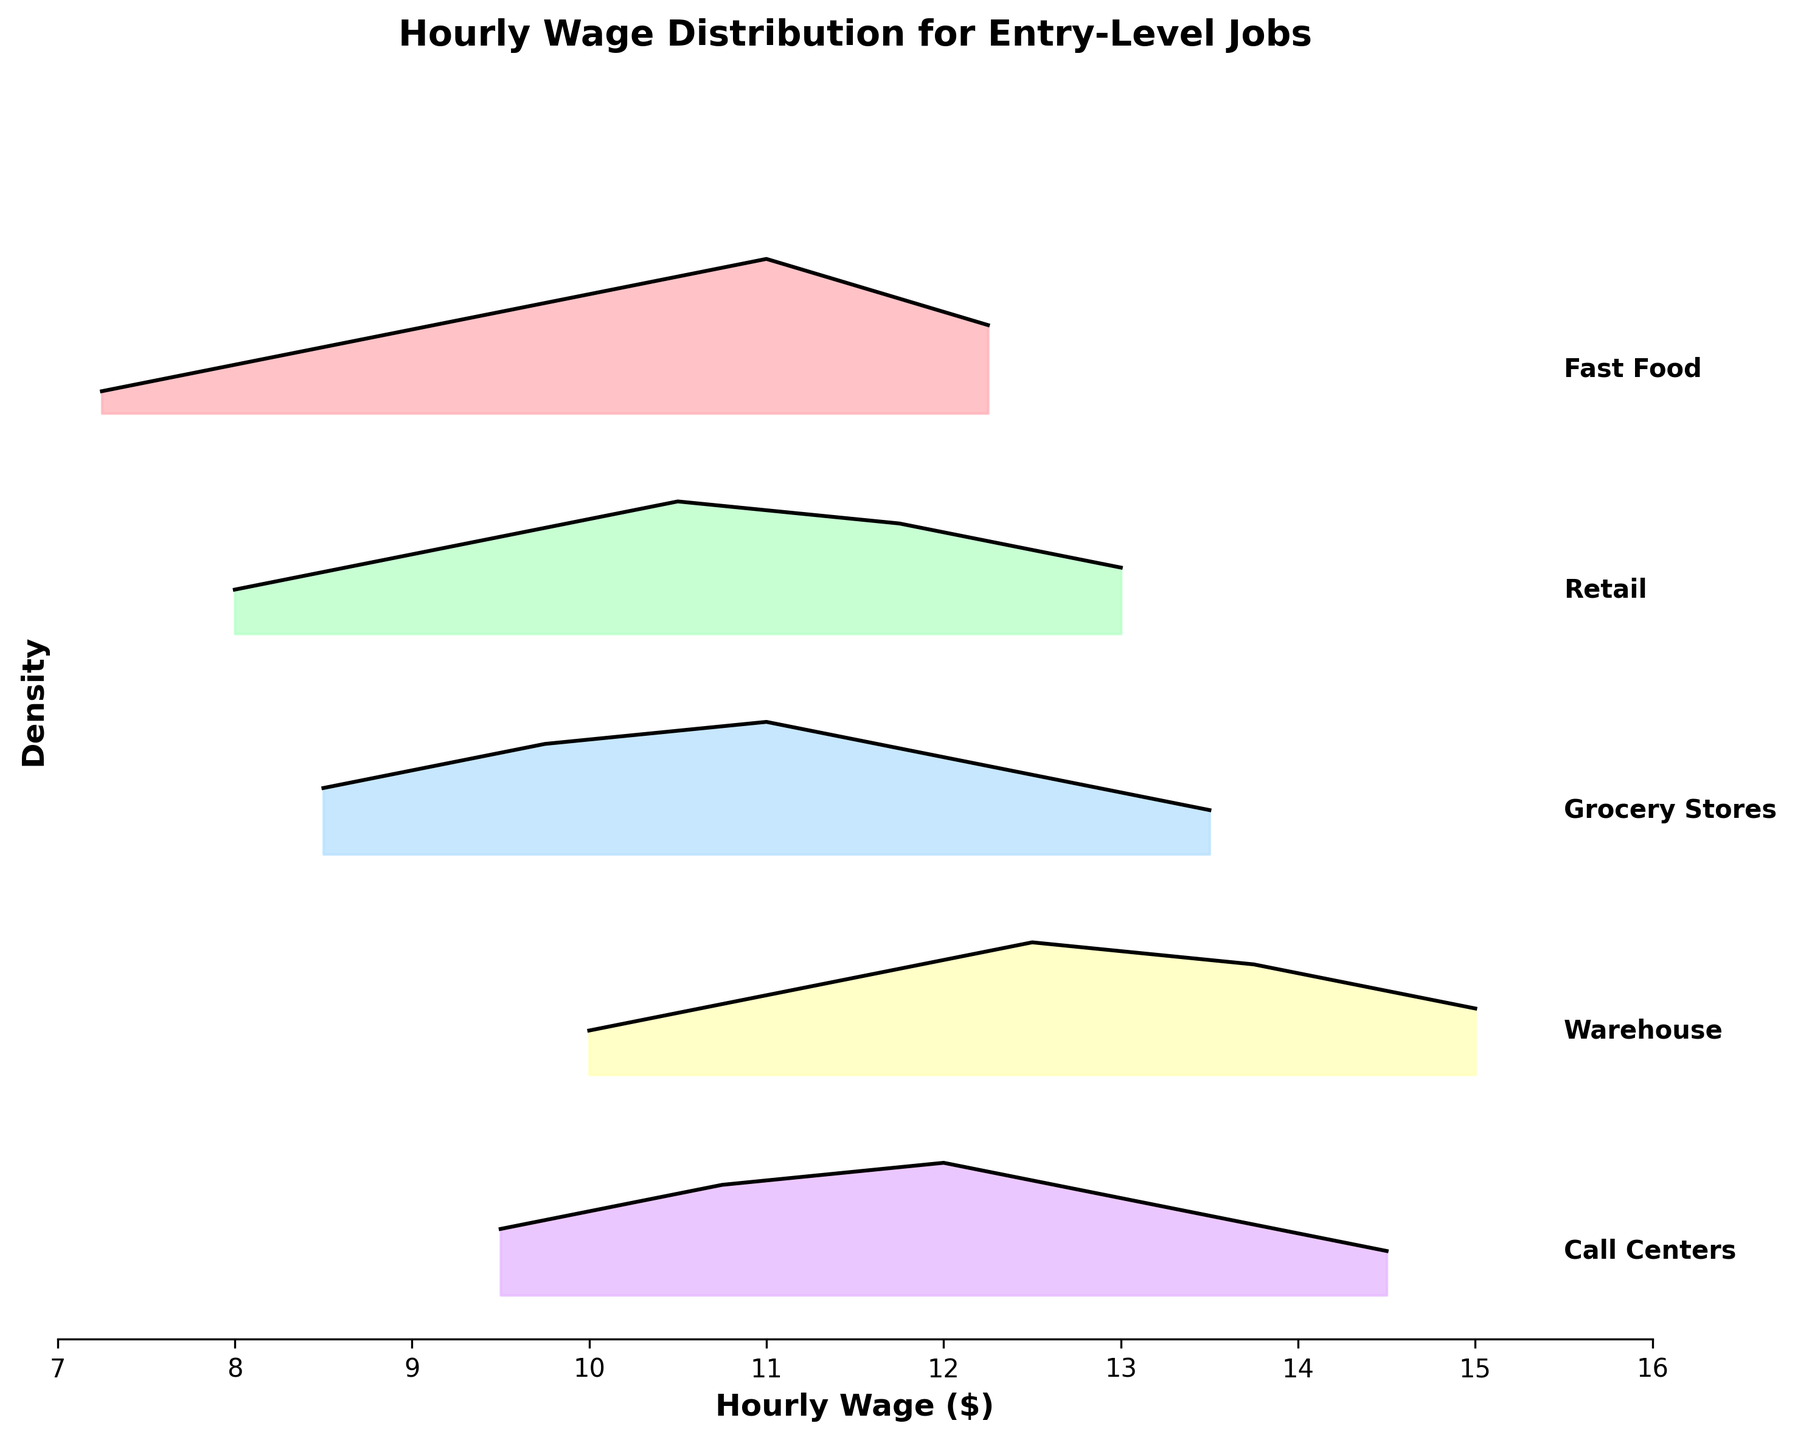What is the title of the figure? The title of the figure is shown at the top in bold text. It reads 'Hourly Wage Distribution for Entry-Level Jobs'.
Answer: Hourly Wage Distribution for Entry-Level Jobs Which industry has the highest density peak? By comparing the peaks of the density curves, the industry with the highest density peak is the Fast Food industry.
Answer: Fast Food What is the range of hourly wages depicted in the plot? The x-axis of the plot, labeled 'Hourly Wage ($)', ranges from $7 to $16.
Answer: $7 to $16 Between Retail and Call Centers, which industry shows higher wages on average? By looking at where the density curves are concentrated along the wage axis, Call Centers show higher wages on average compared to Retail.
Answer: Call Centers How does the density spread of Warehouse jobs compare to that of Grocery Stores? The density curve for Warehouse jobs is more spread out over higher wages ($10 to $15) compared to Grocery Stores, which is more centered around lower-to-mid wages ($8.5 to $13.5).
Answer: Warehouse jobs are more spread out over higher wages Which industry has the widest range of wages? By examining the width of density curves, Warehouse has the widest range of wages from $10 to $15.
Answer: Warehouse How many different industries are shown in the plot? The number of different industries can be counted from the labels on the y-axis. There are five industries labeled: Fast Food, Retail, Grocery Stores, Warehouse, and Call Centers.
Answer: 5 Between Fast Food and Retail jobs, which has a higher density at $11 per hour? By comparing the height of the density curves at $11 per hour, Fast Food has a higher density than Retail.
Answer: Fast Food At approximately what wage does the Call Centers industry show its highest density? The Call Centers density curve peaks around $12 per hour.
Answer: $12 per hour 